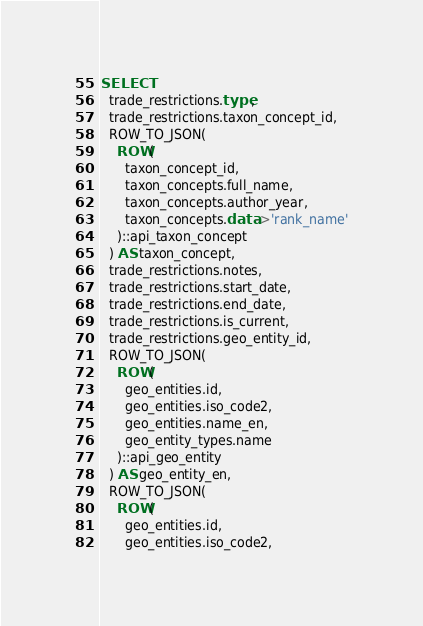<code> <loc_0><loc_0><loc_500><loc_500><_SQL_>SELECT
  trade_restrictions.type,
  trade_restrictions.taxon_concept_id,
  ROW_TO_JSON(
    ROW(
      taxon_concept_id,
      taxon_concepts.full_name,
      taxon_concepts.author_year,
      taxon_concepts.data->'rank_name'
    )::api_taxon_concept
  ) AS taxon_concept,
  trade_restrictions.notes,
  trade_restrictions.start_date,
  trade_restrictions.end_date,
  trade_restrictions.is_current,
  trade_restrictions.geo_entity_id,
  ROW_TO_JSON(
    ROW(
      geo_entities.id,
      geo_entities.iso_code2,
      geo_entities.name_en,
      geo_entity_types.name
    )::api_geo_entity
  ) AS geo_entity_en,
  ROW_TO_JSON(
    ROW(
      geo_entities.id,
      geo_entities.iso_code2,</code> 